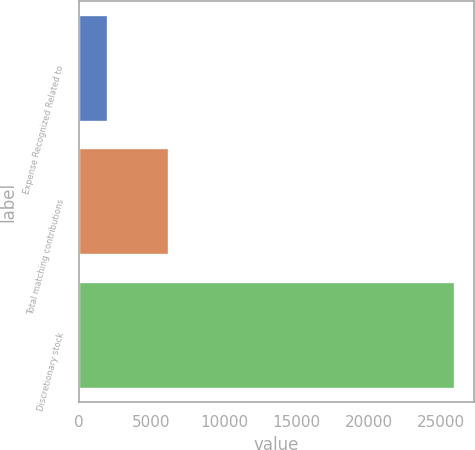Convert chart to OTSL. <chart><loc_0><loc_0><loc_500><loc_500><bar_chart><fcel>Expense Recognized Related to<fcel>Total matching contributions<fcel>Discretionary stock<nl><fcel>2014<fcel>6222<fcel>25972<nl></chart> 